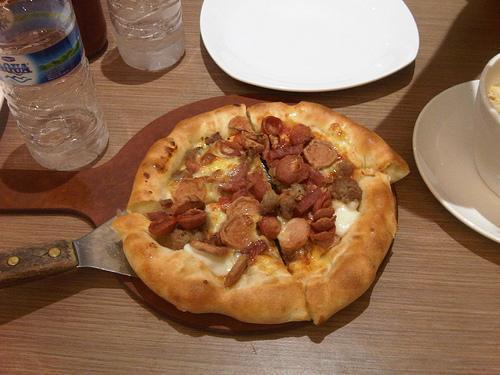What is under the food?
Choose the right answer from the provided options to respond to the question.
Options: Box, spatula, sugar, egg. Spatula. 